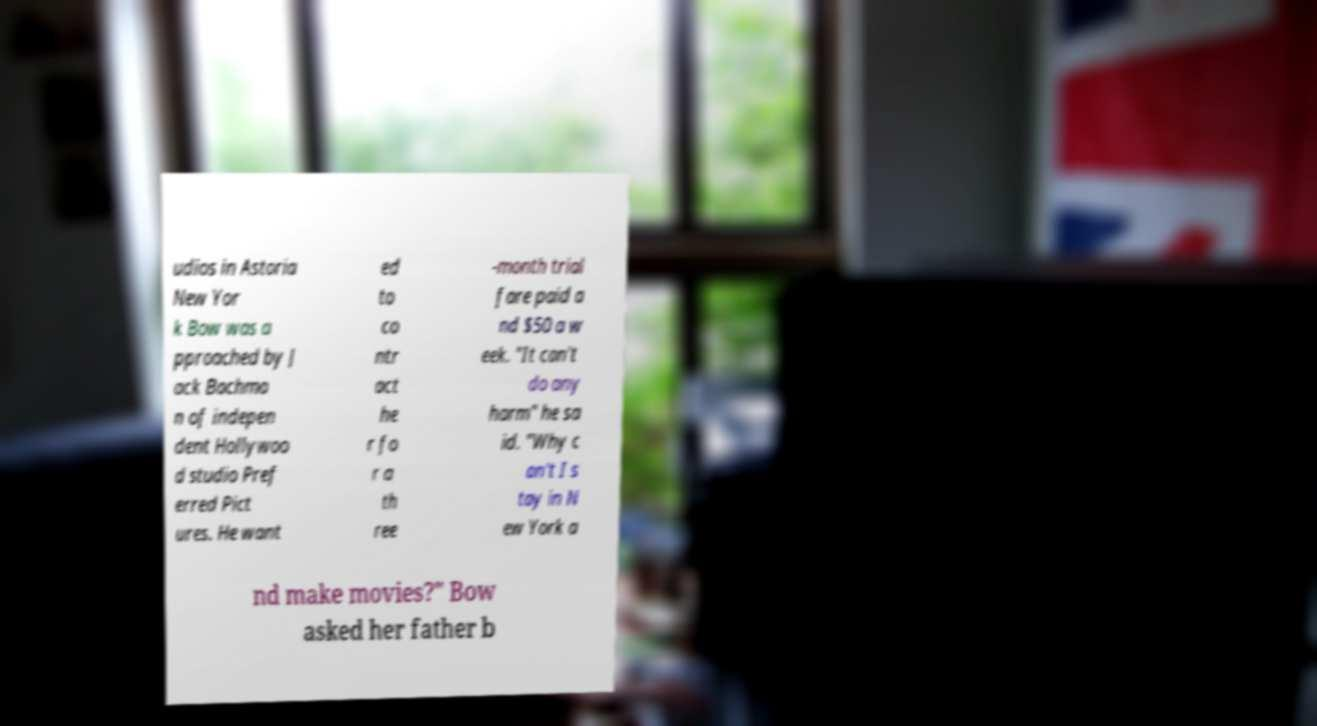For documentation purposes, I need the text within this image transcribed. Could you provide that? udios in Astoria New Yor k Bow was a pproached by J ack Bachma n of indepen dent Hollywoo d studio Pref erred Pict ures. He want ed to co ntr act he r fo r a th ree -month trial fare paid a nd $50 a w eek. "It can't do any harm" he sa id. "Why c an't I s tay in N ew York a nd make movies?" Bow asked her father b 